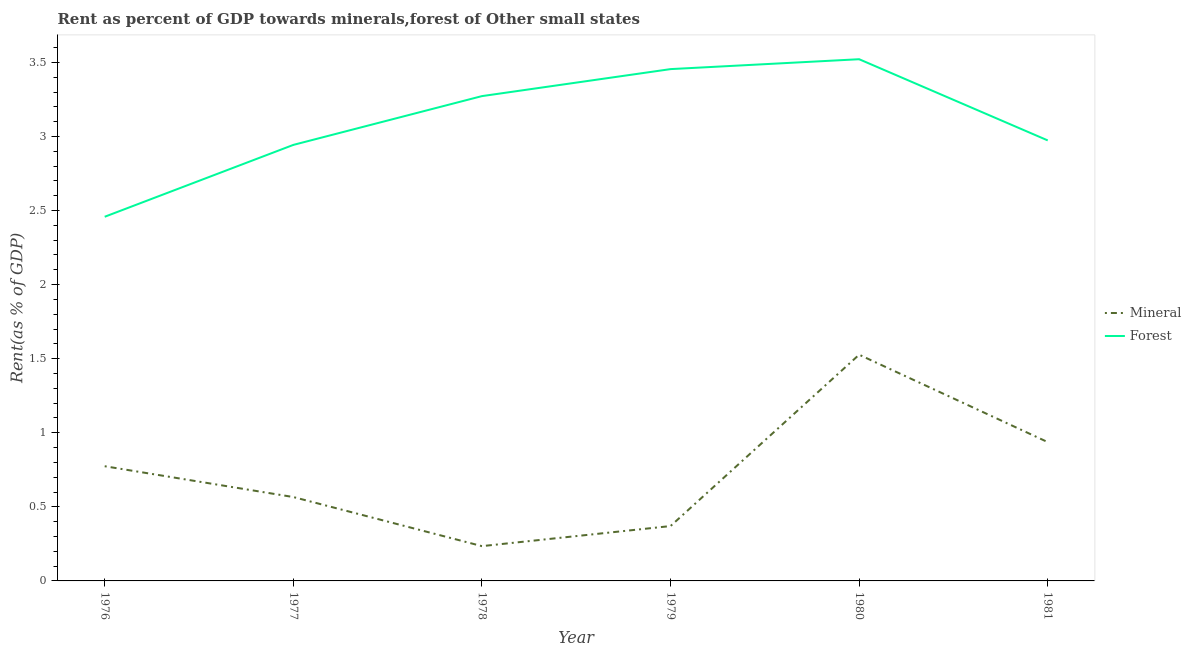What is the forest rent in 1978?
Provide a short and direct response. 3.27. Across all years, what is the maximum mineral rent?
Offer a terse response. 1.53. Across all years, what is the minimum forest rent?
Your answer should be compact. 2.46. In which year was the forest rent minimum?
Offer a terse response. 1976. What is the total forest rent in the graph?
Ensure brevity in your answer.  18.62. What is the difference between the forest rent in 1978 and that in 1981?
Your answer should be compact. 0.3. What is the difference between the mineral rent in 1981 and the forest rent in 1980?
Provide a succinct answer. -2.58. What is the average mineral rent per year?
Your answer should be compact. 0.73. In the year 1980, what is the difference between the forest rent and mineral rent?
Ensure brevity in your answer.  1.99. In how many years, is the forest rent greater than 1.6 %?
Your answer should be very brief. 6. What is the ratio of the forest rent in 1978 to that in 1981?
Keep it short and to the point. 1.1. What is the difference between the highest and the second highest forest rent?
Keep it short and to the point. 0.07. What is the difference between the highest and the lowest mineral rent?
Your answer should be very brief. 1.29. Is the sum of the mineral rent in 1977 and 1979 greater than the maximum forest rent across all years?
Your answer should be very brief. No. Does the forest rent monotonically increase over the years?
Make the answer very short. No. How many years are there in the graph?
Your answer should be very brief. 6. What is the difference between two consecutive major ticks on the Y-axis?
Keep it short and to the point. 0.5. How many legend labels are there?
Provide a succinct answer. 2. How are the legend labels stacked?
Make the answer very short. Vertical. What is the title of the graph?
Make the answer very short. Rent as percent of GDP towards minerals,forest of Other small states. What is the label or title of the Y-axis?
Offer a terse response. Rent(as % of GDP). What is the Rent(as % of GDP) in Mineral in 1976?
Your answer should be very brief. 0.77. What is the Rent(as % of GDP) of Forest in 1976?
Your answer should be very brief. 2.46. What is the Rent(as % of GDP) in Mineral in 1977?
Provide a succinct answer. 0.57. What is the Rent(as % of GDP) of Forest in 1977?
Your answer should be very brief. 2.94. What is the Rent(as % of GDP) in Mineral in 1978?
Offer a very short reply. 0.23. What is the Rent(as % of GDP) of Forest in 1978?
Make the answer very short. 3.27. What is the Rent(as % of GDP) of Mineral in 1979?
Your answer should be compact. 0.37. What is the Rent(as % of GDP) of Forest in 1979?
Ensure brevity in your answer.  3.45. What is the Rent(as % of GDP) in Mineral in 1980?
Keep it short and to the point. 1.53. What is the Rent(as % of GDP) in Forest in 1980?
Offer a very short reply. 3.52. What is the Rent(as % of GDP) of Mineral in 1981?
Provide a succinct answer. 0.94. What is the Rent(as % of GDP) in Forest in 1981?
Your answer should be very brief. 2.97. Across all years, what is the maximum Rent(as % of GDP) in Mineral?
Your answer should be very brief. 1.53. Across all years, what is the maximum Rent(as % of GDP) of Forest?
Ensure brevity in your answer.  3.52. Across all years, what is the minimum Rent(as % of GDP) of Mineral?
Give a very brief answer. 0.23. Across all years, what is the minimum Rent(as % of GDP) of Forest?
Give a very brief answer. 2.46. What is the total Rent(as % of GDP) of Mineral in the graph?
Your answer should be compact. 4.41. What is the total Rent(as % of GDP) in Forest in the graph?
Your answer should be compact. 18.62. What is the difference between the Rent(as % of GDP) of Mineral in 1976 and that in 1977?
Your answer should be very brief. 0.21. What is the difference between the Rent(as % of GDP) in Forest in 1976 and that in 1977?
Provide a short and direct response. -0.48. What is the difference between the Rent(as % of GDP) in Mineral in 1976 and that in 1978?
Provide a succinct answer. 0.54. What is the difference between the Rent(as % of GDP) in Forest in 1976 and that in 1978?
Your answer should be compact. -0.81. What is the difference between the Rent(as % of GDP) of Mineral in 1976 and that in 1979?
Your answer should be very brief. 0.4. What is the difference between the Rent(as % of GDP) of Forest in 1976 and that in 1979?
Your answer should be compact. -1. What is the difference between the Rent(as % of GDP) of Mineral in 1976 and that in 1980?
Your answer should be compact. -0.75. What is the difference between the Rent(as % of GDP) of Forest in 1976 and that in 1980?
Provide a short and direct response. -1.06. What is the difference between the Rent(as % of GDP) of Mineral in 1976 and that in 1981?
Your answer should be compact. -0.16. What is the difference between the Rent(as % of GDP) in Forest in 1976 and that in 1981?
Keep it short and to the point. -0.52. What is the difference between the Rent(as % of GDP) of Mineral in 1977 and that in 1978?
Provide a succinct answer. 0.33. What is the difference between the Rent(as % of GDP) of Forest in 1977 and that in 1978?
Provide a succinct answer. -0.33. What is the difference between the Rent(as % of GDP) in Mineral in 1977 and that in 1979?
Ensure brevity in your answer.  0.2. What is the difference between the Rent(as % of GDP) in Forest in 1977 and that in 1979?
Keep it short and to the point. -0.51. What is the difference between the Rent(as % of GDP) of Mineral in 1977 and that in 1980?
Ensure brevity in your answer.  -0.96. What is the difference between the Rent(as % of GDP) of Forest in 1977 and that in 1980?
Your answer should be compact. -0.58. What is the difference between the Rent(as % of GDP) in Mineral in 1977 and that in 1981?
Provide a succinct answer. -0.37. What is the difference between the Rent(as % of GDP) in Forest in 1977 and that in 1981?
Offer a terse response. -0.03. What is the difference between the Rent(as % of GDP) in Mineral in 1978 and that in 1979?
Offer a terse response. -0.14. What is the difference between the Rent(as % of GDP) in Forest in 1978 and that in 1979?
Offer a terse response. -0.18. What is the difference between the Rent(as % of GDP) of Mineral in 1978 and that in 1980?
Your answer should be compact. -1.29. What is the difference between the Rent(as % of GDP) of Forest in 1978 and that in 1980?
Keep it short and to the point. -0.25. What is the difference between the Rent(as % of GDP) of Mineral in 1978 and that in 1981?
Offer a terse response. -0.7. What is the difference between the Rent(as % of GDP) of Forest in 1978 and that in 1981?
Offer a very short reply. 0.3. What is the difference between the Rent(as % of GDP) of Mineral in 1979 and that in 1980?
Your answer should be very brief. -1.16. What is the difference between the Rent(as % of GDP) of Forest in 1979 and that in 1980?
Give a very brief answer. -0.07. What is the difference between the Rent(as % of GDP) of Mineral in 1979 and that in 1981?
Provide a succinct answer. -0.57. What is the difference between the Rent(as % of GDP) of Forest in 1979 and that in 1981?
Make the answer very short. 0.48. What is the difference between the Rent(as % of GDP) of Mineral in 1980 and that in 1981?
Ensure brevity in your answer.  0.59. What is the difference between the Rent(as % of GDP) in Forest in 1980 and that in 1981?
Your answer should be compact. 0.55. What is the difference between the Rent(as % of GDP) of Mineral in 1976 and the Rent(as % of GDP) of Forest in 1977?
Make the answer very short. -2.17. What is the difference between the Rent(as % of GDP) of Mineral in 1976 and the Rent(as % of GDP) of Forest in 1978?
Keep it short and to the point. -2.5. What is the difference between the Rent(as % of GDP) of Mineral in 1976 and the Rent(as % of GDP) of Forest in 1979?
Provide a succinct answer. -2.68. What is the difference between the Rent(as % of GDP) in Mineral in 1976 and the Rent(as % of GDP) in Forest in 1980?
Your answer should be compact. -2.75. What is the difference between the Rent(as % of GDP) in Mineral in 1976 and the Rent(as % of GDP) in Forest in 1981?
Ensure brevity in your answer.  -2.2. What is the difference between the Rent(as % of GDP) in Mineral in 1977 and the Rent(as % of GDP) in Forest in 1978?
Keep it short and to the point. -2.71. What is the difference between the Rent(as % of GDP) of Mineral in 1977 and the Rent(as % of GDP) of Forest in 1979?
Offer a terse response. -2.89. What is the difference between the Rent(as % of GDP) in Mineral in 1977 and the Rent(as % of GDP) in Forest in 1980?
Provide a short and direct response. -2.96. What is the difference between the Rent(as % of GDP) of Mineral in 1977 and the Rent(as % of GDP) of Forest in 1981?
Provide a succinct answer. -2.41. What is the difference between the Rent(as % of GDP) of Mineral in 1978 and the Rent(as % of GDP) of Forest in 1979?
Your answer should be compact. -3.22. What is the difference between the Rent(as % of GDP) of Mineral in 1978 and the Rent(as % of GDP) of Forest in 1980?
Provide a succinct answer. -3.29. What is the difference between the Rent(as % of GDP) in Mineral in 1978 and the Rent(as % of GDP) in Forest in 1981?
Keep it short and to the point. -2.74. What is the difference between the Rent(as % of GDP) in Mineral in 1979 and the Rent(as % of GDP) in Forest in 1980?
Ensure brevity in your answer.  -3.15. What is the difference between the Rent(as % of GDP) in Mineral in 1979 and the Rent(as % of GDP) in Forest in 1981?
Your response must be concise. -2.6. What is the difference between the Rent(as % of GDP) in Mineral in 1980 and the Rent(as % of GDP) in Forest in 1981?
Provide a succinct answer. -1.45. What is the average Rent(as % of GDP) in Mineral per year?
Your answer should be compact. 0.73. What is the average Rent(as % of GDP) in Forest per year?
Provide a succinct answer. 3.1. In the year 1976, what is the difference between the Rent(as % of GDP) in Mineral and Rent(as % of GDP) in Forest?
Provide a short and direct response. -1.68. In the year 1977, what is the difference between the Rent(as % of GDP) in Mineral and Rent(as % of GDP) in Forest?
Give a very brief answer. -2.38. In the year 1978, what is the difference between the Rent(as % of GDP) of Mineral and Rent(as % of GDP) of Forest?
Provide a succinct answer. -3.04. In the year 1979, what is the difference between the Rent(as % of GDP) in Mineral and Rent(as % of GDP) in Forest?
Offer a terse response. -3.08. In the year 1980, what is the difference between the Rent(as % of GDP) in Mineral and Rent(as % of GDP) in Forest?
Keep it short and to the point. -1.99. In the year 1981, what is the difference between the Rent(as % of GDP) in Mineral and Rent(as % of GDP) in Forest?
Make the answer very short. -2.04. What is the ratio of the Rent(as % of GDP) of Mineral in 1976 to that in 1977?
Give a very brief answer. 1.37. What is the ratio of the Rent(as % of GDP) of Forest in 1976 to that in 1977?
Your answer should be compact. 0.84. What is the ratio of the Rent(as % of GDP) in Mineral in 1976 to that in 1978?
Give a very brief answer. 3.3. What is the ratio of the Rent(as % of GDP) in Forest in 1976 to that in 1978?
Keep it short and to the point. 0.75. What is the ratio of the Rent(as % of GDP) in Mineral in 1976 to that in 1979?
Keep it short and to the point. 2.09. What is the ratio of the Rent(as % of GDP) in Forest in 1976 to that in 1979?
Your answer should be compact. 0.71. What is the ratio of the Rent(as % of GDP) in Mineral in 1976 to that in 1980?
Your answer should be compact. 0.51. What is the ratio of the Rent(as % of GDP) of Forest in 1976 to that in 1980?
Your answer should be very brief. 0.7. What is the ratio of the Rent(as % of GDP) in Mineral in 1976 to that in 1981?
Offer a terse response. 0.83. What is the ratio of the Rent(as % of GDP) in Forest in 1976 to that in 1981?
Ensure brevity in your answer.  0.83. What is the ratio of the Rent(as % of GDP) of Mineral in 1977 to that in 1978?
Your answer should be compact. 2.41. What is the ratio of the Rent(as % of GDP) in Forest in 1977 to that in 1978?
Ensure brevity in your answer.  0.9. What is the ratio of the Rent(as % of GDP) in Mineral in 1977 to that in 1979?
Your response must be concise. 1.53. What is the ratio of the Rent(as % of GDP) in Forest in 1977 to that in 1979?
Give a very brief answer. 0.85. What is the ratio of the Rent(as % of GDP) in Mineral in 1977 to that in 1980?
Your answer should be compact. 0.37. What is the ratio of the Rent(as % of GDP) of Forest in 1977 to that in 1980?
Ensure brevity in your answer.  0.84. What is the ratio of the Rent(as % of GDP) in Mineral in 1977 to that in 1981?
Ensure brevity in your answer.  0.6. What is the ratio of the Rent(as % of GDP) in Mineral in 1978 to that in 1979?
Your response must be concise. 0.63. What is the ratio of the Rent(as % of GDP) of Forest in 1978 to that in 1979?
Your answer should be compact. 0.95. What is the ratio of the Rent(as % of GDP) in Mineral in 1978 to that in 1980?
Your response must be concise. 0.15. What is the ratio of the Rent(as % of GDP) of Forest in 1978 to that in 1980?
Give a very brief answer. 0.93. What is the ratio of the Rent(as % of GDP) of Mineral in 1978 to that in 1981?
Offer a very short reply. 0.25. What is the ratio of the Rent(as % of GDP) of Forest in 1978 to that in 1981?
Offer a very short reply. 1.1. What is the ratio of the Rent(as % of GDP) in Mineral in 1979 to that in 1980?
Offer a terse response. 0.24. What is the ratio of the Rent(as % of GDP) in Mineral in 1979 to that in 1981?
Offer a very short reply. 0.4. What is the ratio of the Rent(as % of GDP) in Forest in 1979 to that in 1981?
Offer a terse response. 1.16. What is the ratio of the Rent(as % of GDP) in Mineral in 1980 to that in 1981?
Offer a very short reply. 1.63. What is the ratio of the Rent(as % of GDP) in Forest in 1980 to that in 1981?
Provide a short and direct response. 1.18. What is the difference between the highest and the second highest Rent(as % of GDP) of Mineral?
Keep it short and to the point. 0.59. What is the difference between the highest and the second highest Rent(as % of GDP) in Forest?
Ensure brevity in your answer.  0.07. What is the difference between the highest and the lowest Rent(as % of GDP) of Mineral?
Provide a short and direct response. 1.29. What is the difference between the highest and the lowest Rent(as % of GDP) of Forest?
Your response must be concise. 1.06. 